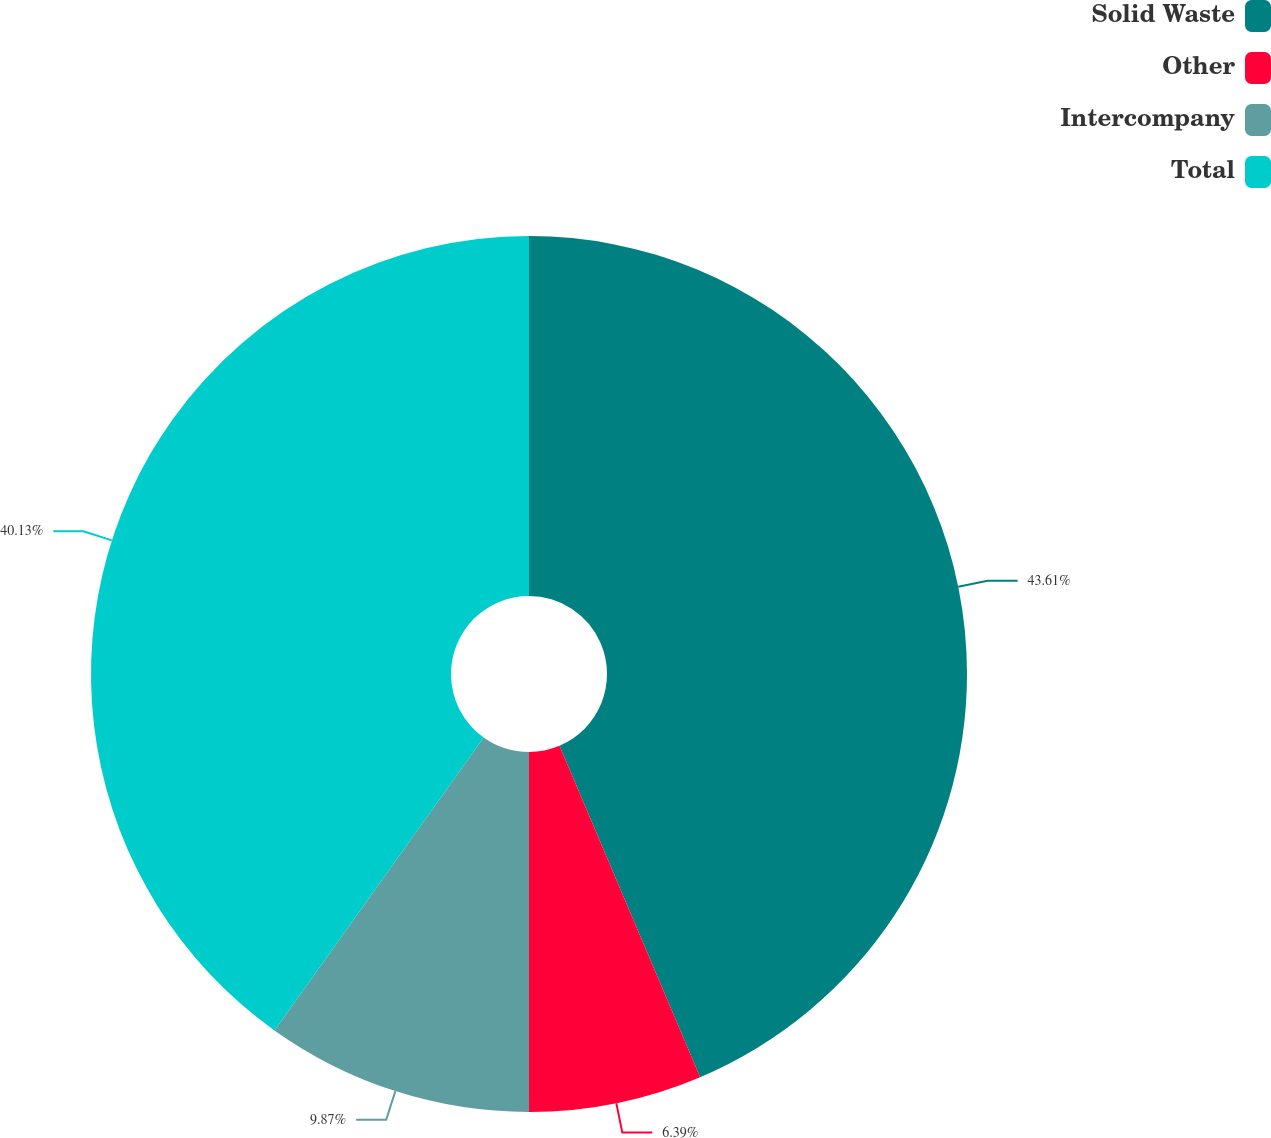Convert chart. <chart><loc_0><loc_0><loc_500><loc_500><pie_chart><fcel>Solid Waste<fcel>Other<fcel>Intercompany<fcel>Total<nl><fcel>43.61%<fcel>6.39%<fcel>9.87%<fcel>40.13%<nl></chart> 